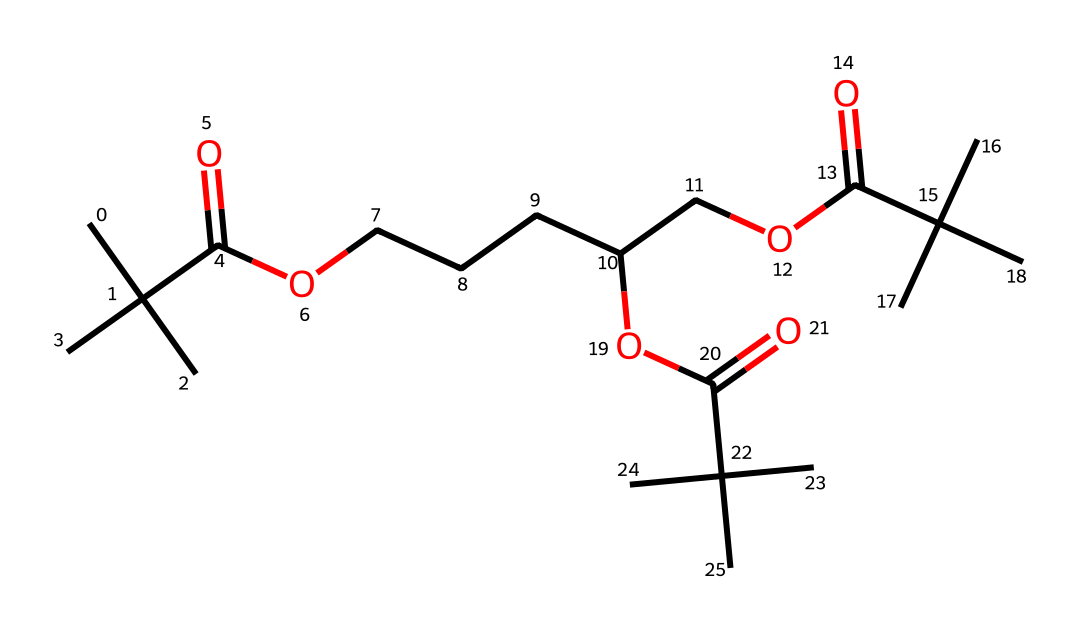What is the molecular formula of this compound? By analyzing the SMILES representation, the number of carbon (C), hydrogen (H), and oxygen (O) atoms can be counted. In total, there are 28 carbon atoms, 54 hydrogen atoms, and 6 oxygen atoms, giving the molecular formula as C28H54O6.
Answer: C28H54O6 How many ester functional groups are present? Looking at the structure implied in the SMILES, the esters are indicated by the "C(=O)O" segments. There are three instances of this pattern in the molecule, showing that there are three ester functional groups.
Answer: 3 What is the degree of branching in the carbon chain? The presence of pentyl groups and the branching indicated by multiple "(C)(C)" in the structure suggests a highly branched molecule. The branching is significant around the functional sites, especially where the carboxylic and ester groups are present.
Answer: highly branched Which groups in this structure are indicative of organometallic properties? The structure itself does not directly feature metal constituents typically found in organometallic compounds; however, the carbonyl and ester functionalities may suggest compatibility in organometallic chemistry applications.
Answer: None How many carbonyl groups exist in this molecule? Each carbonyl group is represented by the carbon atom directly connected to a double-bonded oxygen (C=O). Within the structure, there are three distinct regions where this occurs.
Answer: 3 